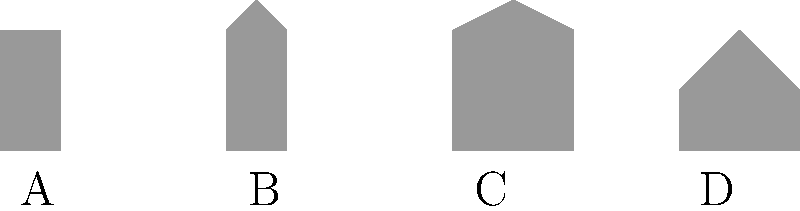As a pastry chef, you're familiar with various tools of the trade. Identify the silhouette that represents a piping bag, an essential tool for decorating cakes and creating intricate designs on pastries. Let's analyze each silhouette:

1. Tool A: This appears to be a rolling pin. It has a cylindrical shape with straight sides, typically used for flattening dough.

2. Tool B: This silhouette resembles a pastry brush. It has a handle and a flared top, used for applying egg wash or glazes to pastries.

3. Tool C: This is the piping bag. It has a wide opening at the top that tapers to a point, perfect for holding and squeezing out icing or cream for decorations.

4. Tool D: This shape suggests a pastry cutter or dough scraper. It has a flat bottom with a curved top, used for cutting dough or cleaning work surfaces.

The piping bag, essential for decorating cakes and creating intricate designs, is represented by silhouette C. Its distinctive conical shape allows for precision in piping and is a staple tool in any pastry chef's kit.
Answer: C 